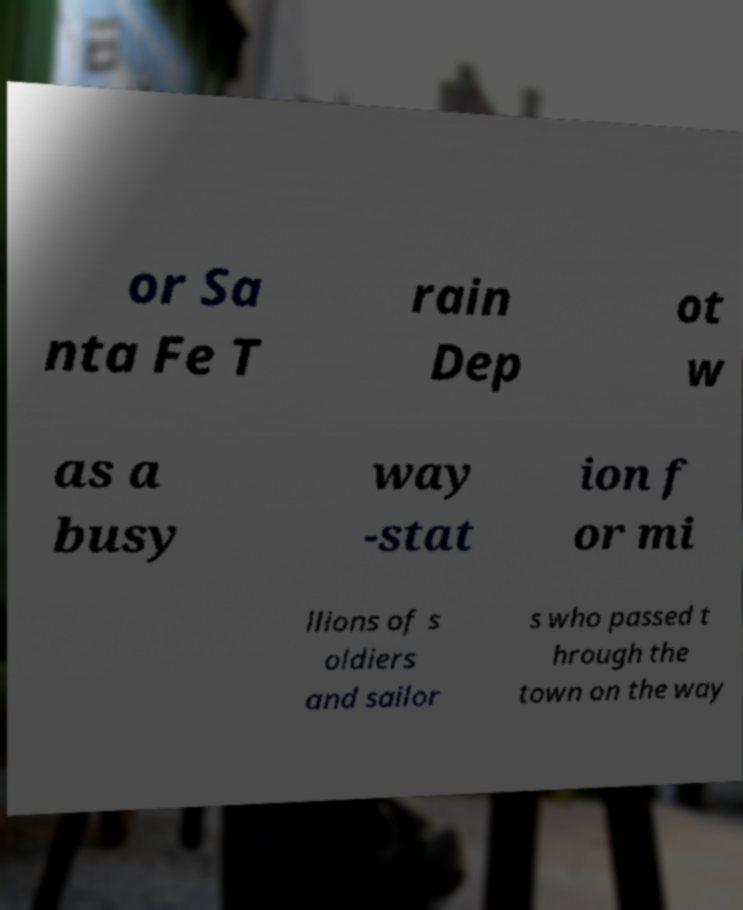I need the written content from this picture converted into text. Can you do that? or Sa nta Fe T rain Dep ot w as a busy way -stat ion f or mi llions of s oldiers and sailor s who passed t hrough the town on the way 